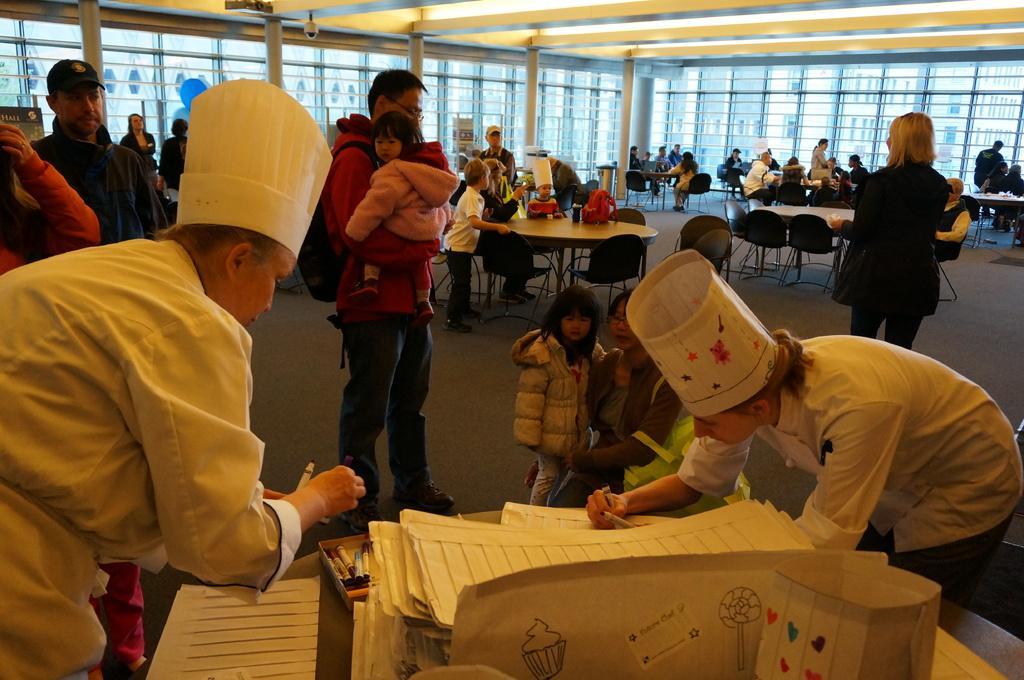Could you give a brief overview of what you see in this image? In this image there is a table in the middle on which there are papers,markers on it and there are two persons who are standing beside the table are writing on the paper. In the background there are tables around which there are few people sitting in the chairs. In the middle there is a table around which there are few people sitting around it. At the top there is ceiling with the lights. In the middle there is a man standing on the floor by holding the kid. 